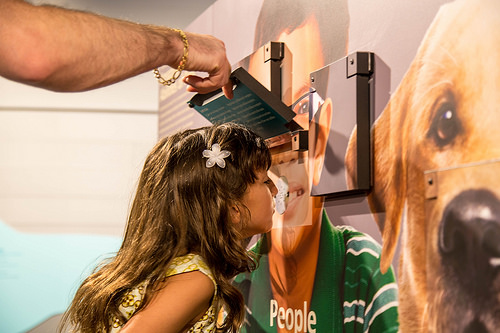<image>
Can you confirm if the dog is on the wall? Yes. Looking at the image, I can see the dog is positioned on top of the wall, with the wall providing support. Is the dog next to the man? Yes. The dog is positioned adjacent to the man, located nearby in the same general area. 